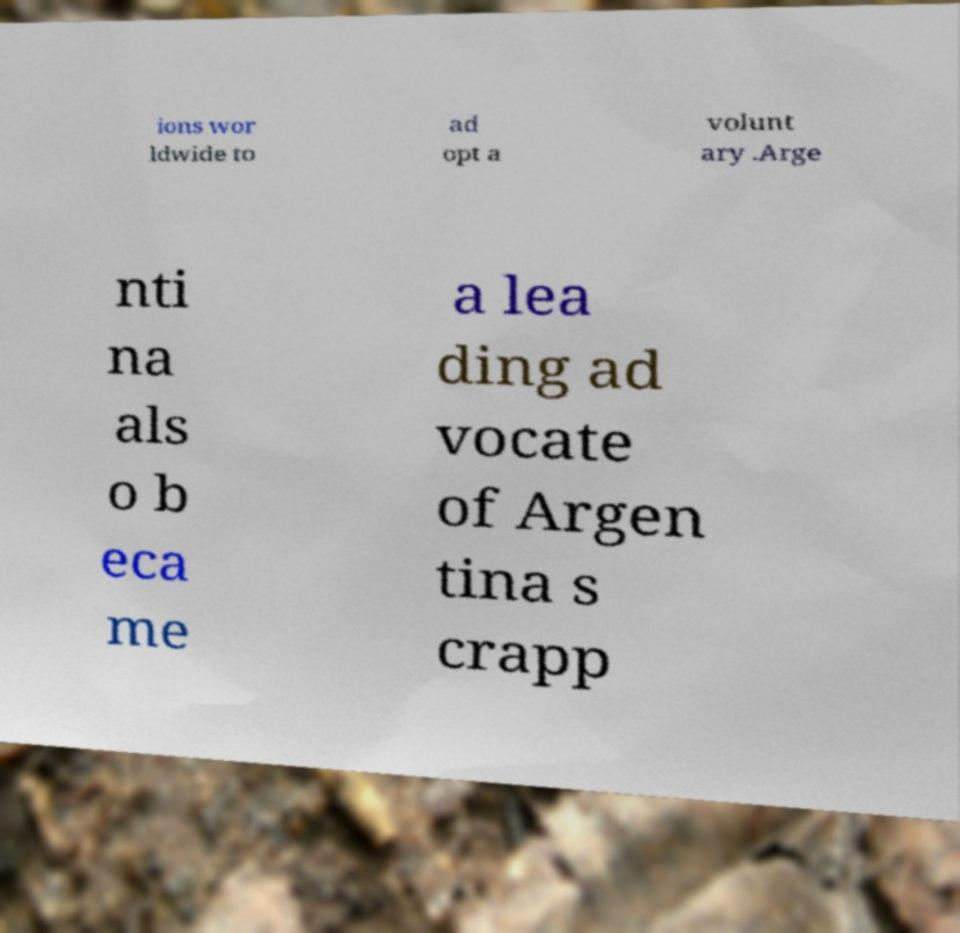Can you read and provide the text displayed in the image?This photo seems to have some interesting text. Can you extract and type it out for me? ions wor ldwide to ad opt a volunt ary .Arge nti na als o b eca me a lea ding ad vocate of Argen tina s crapp 